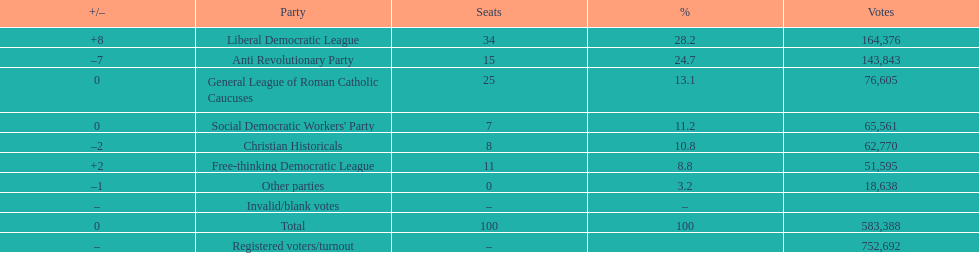How many more votes did the liberal democratic league win over the free-thinking democratic league? 112,781. 